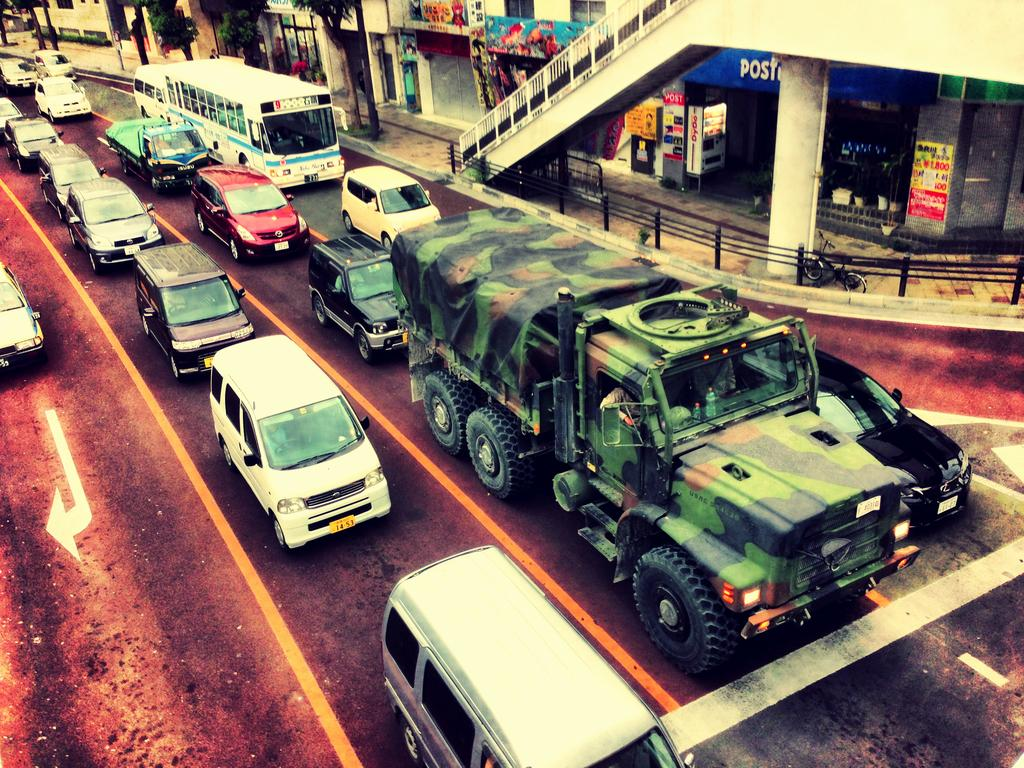What types of vehicles are present in the image? There are cars, a bus, and a truck in the image. What else can be seen in the image besides vehicles? There are stores, trees, a bicycle, and stairs visible in the image. Can you see a snake slithering through the image? There is no snake present in the image. What type of stone is used to build the stairs in the image? There is no information about the type of stone used to build the stairs in the image. 